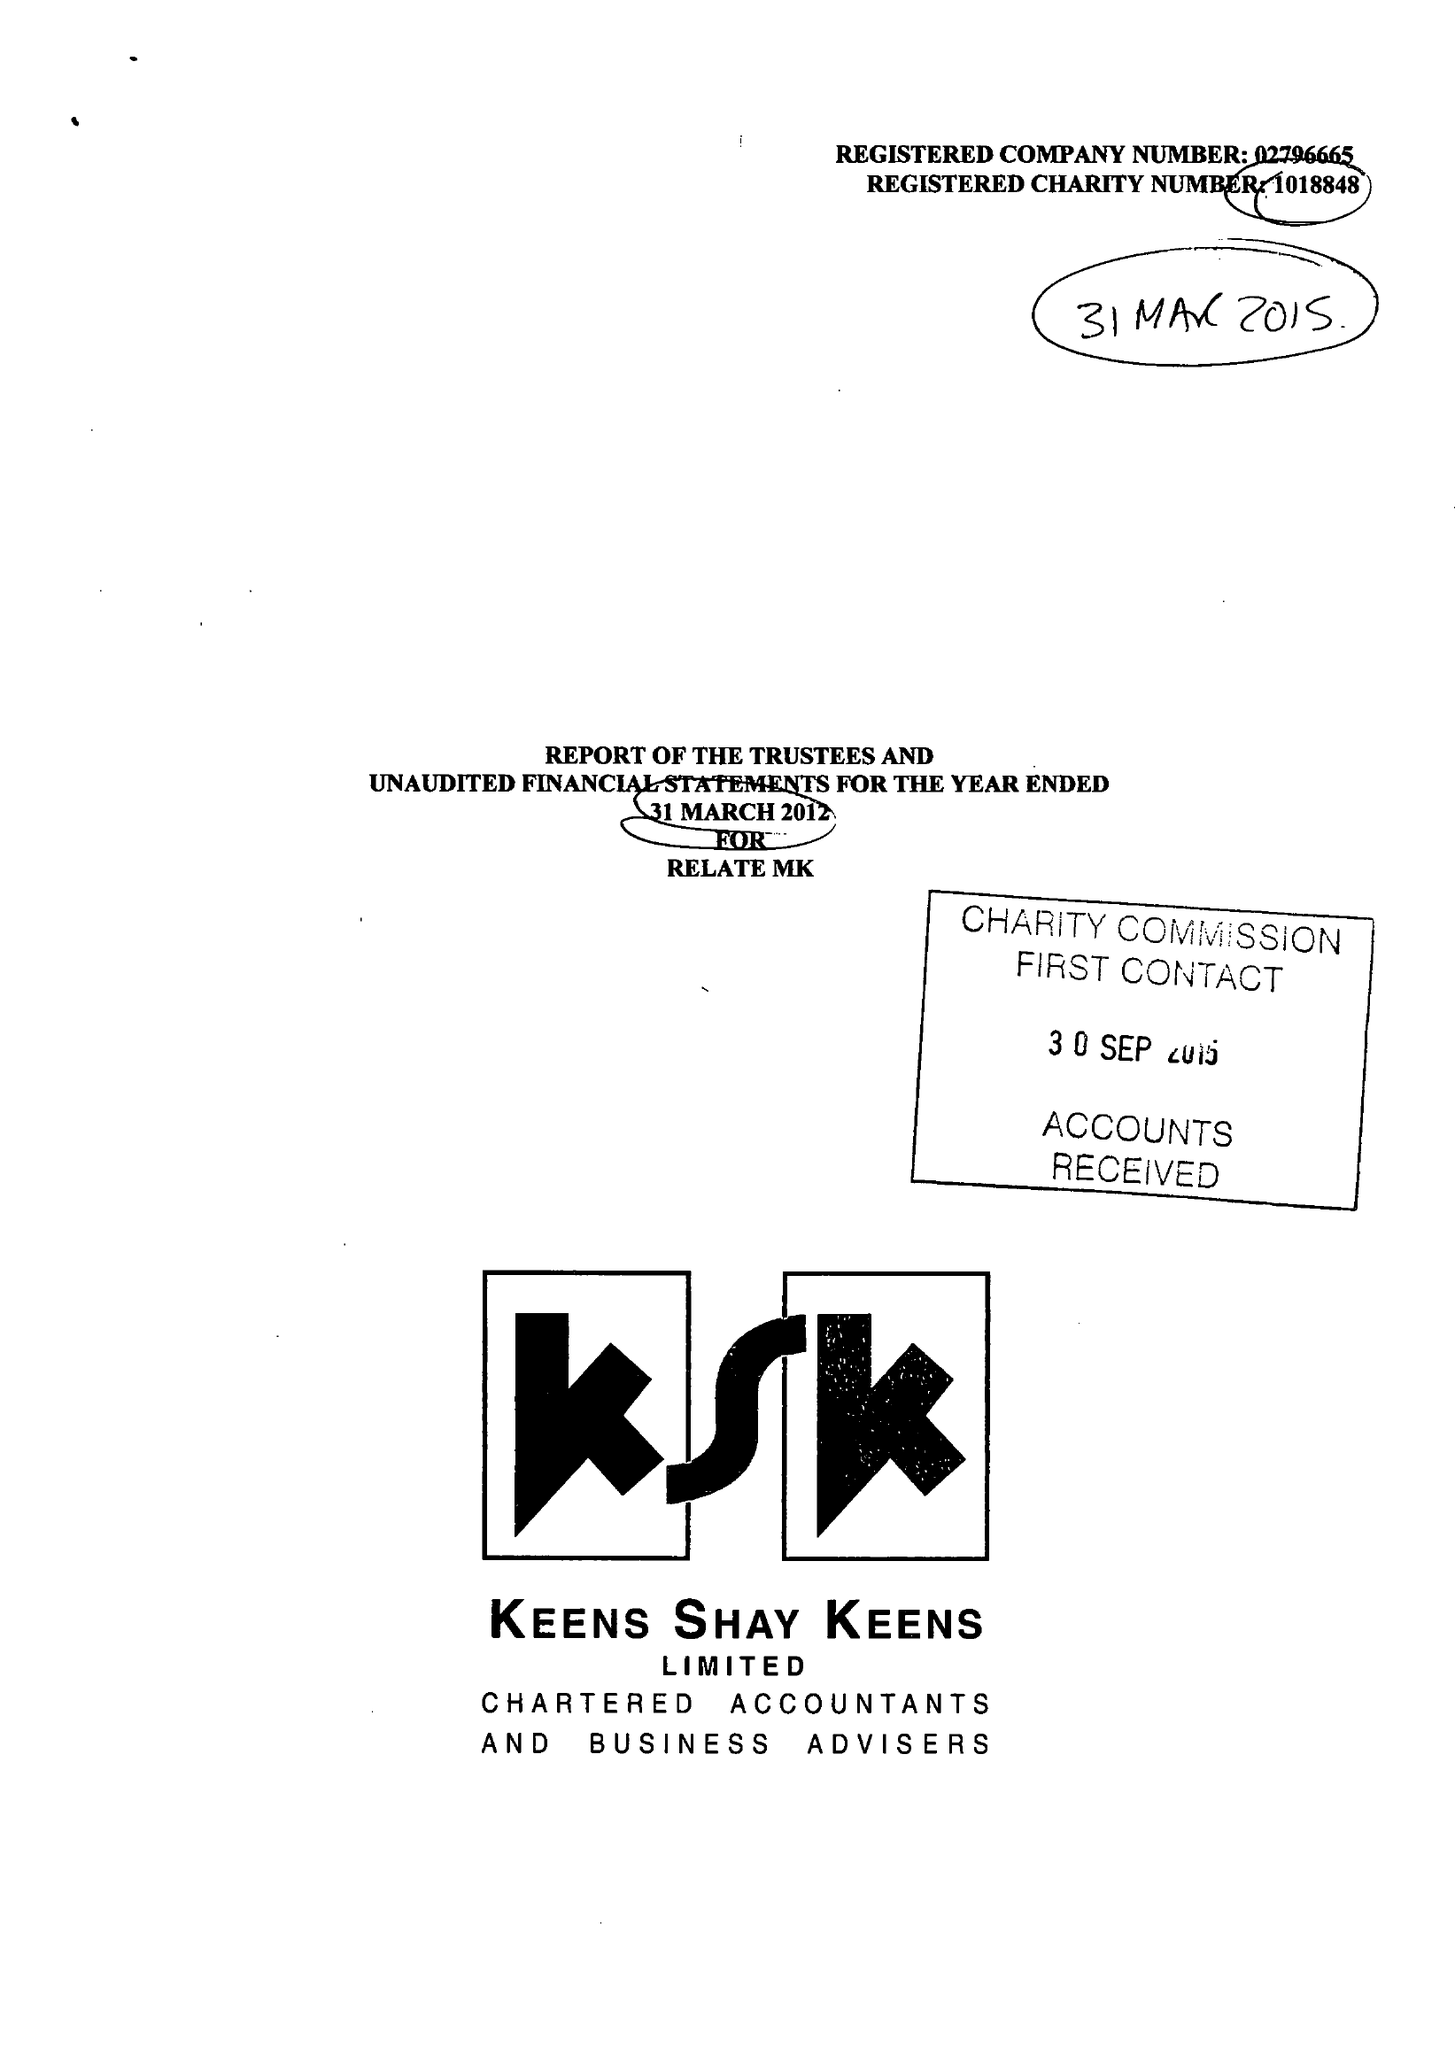What is the value for the address__street_line?
Answer the question using a single word or phrase. 47 AYLESBURY STREET 